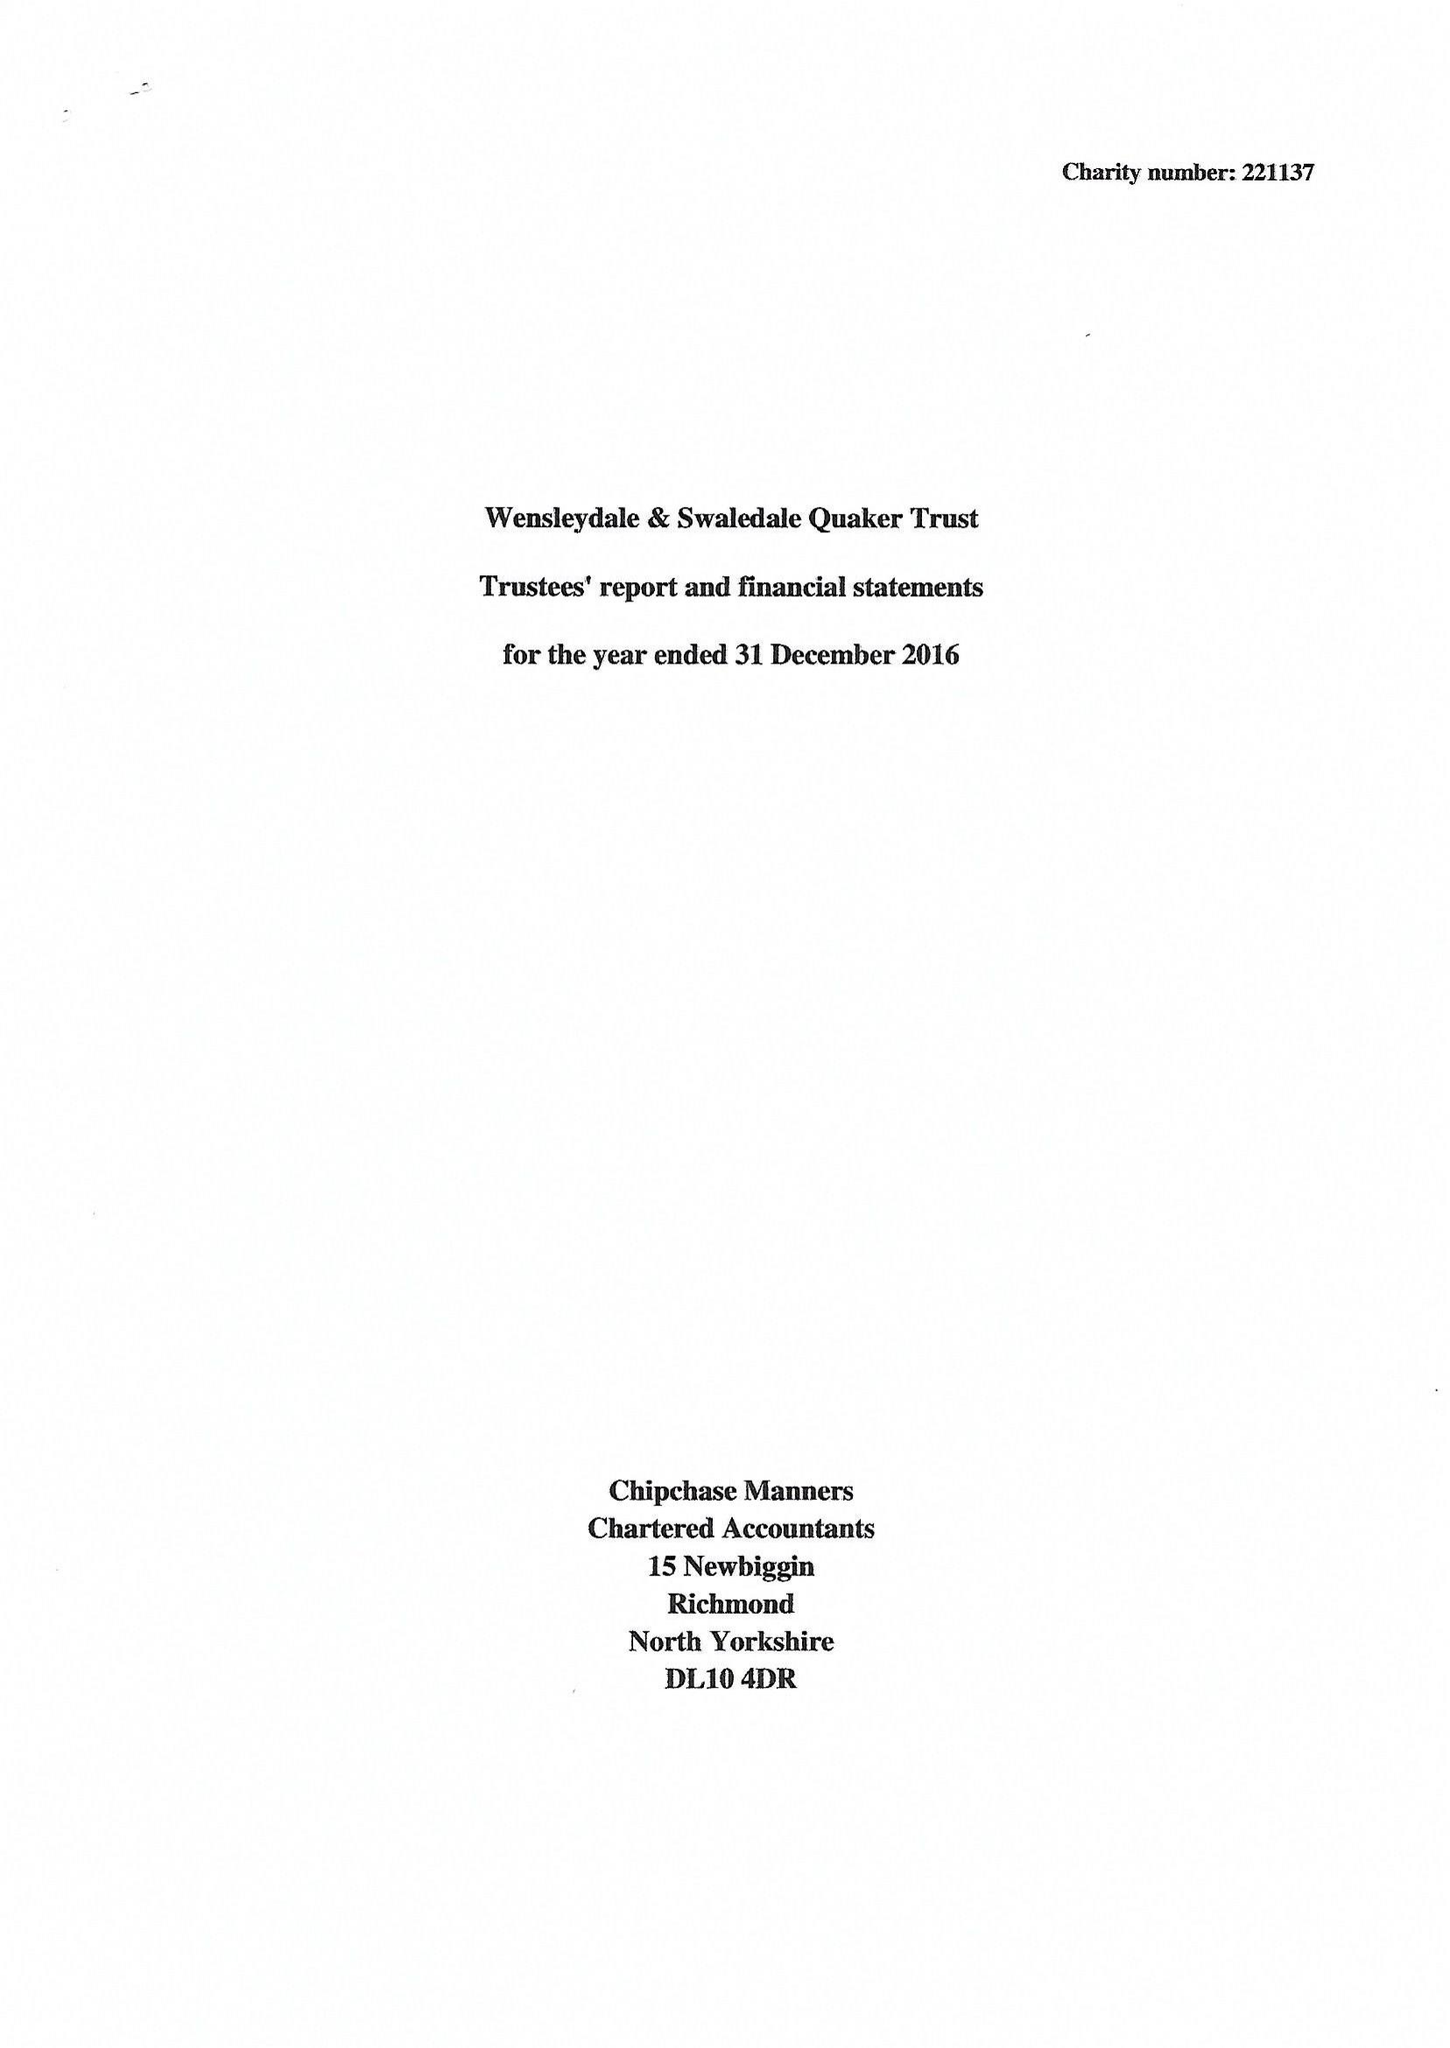What is the value for the address__street_line?
Answer the question using a single word or phrase. 7 GROVE SQUARE 